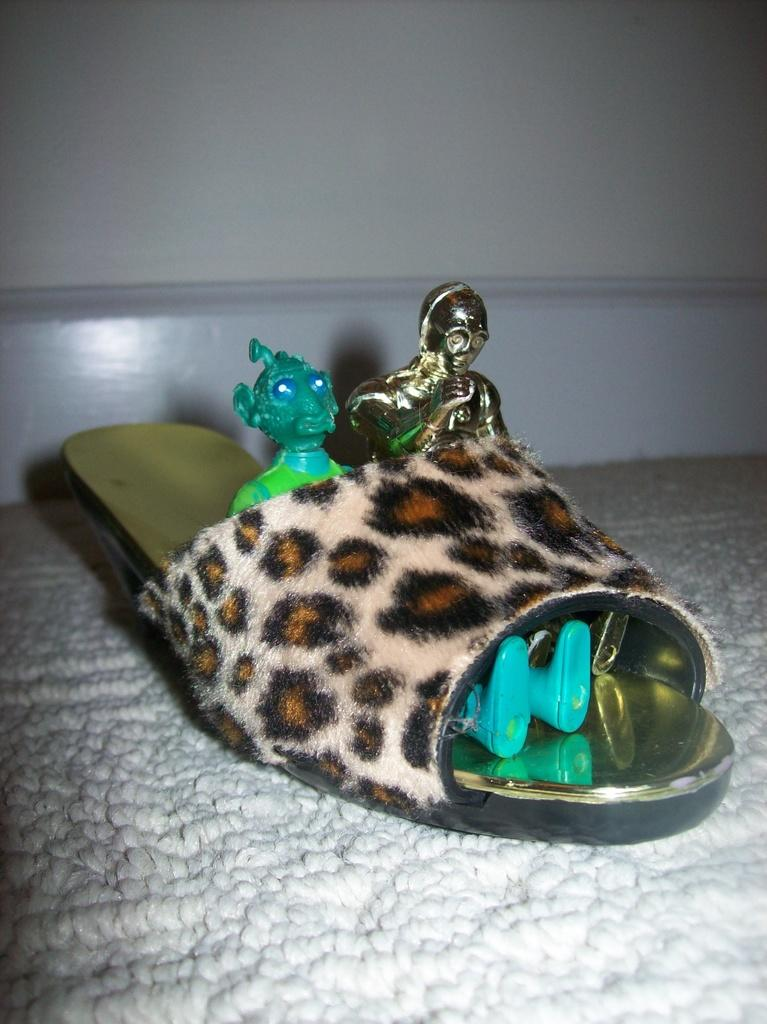What is placed on the footwear in the image? There are toys on the footwear. On what is the footwear placed? The footwear is placed on a white cloth. What can be seen in the background of the image? There is a wall in the background of the image. What type of payment is being made by the doctor in the image? There is no doctor or payment present in the image; it features toys on a footwear placed on a white cloth with a wall in the background. 